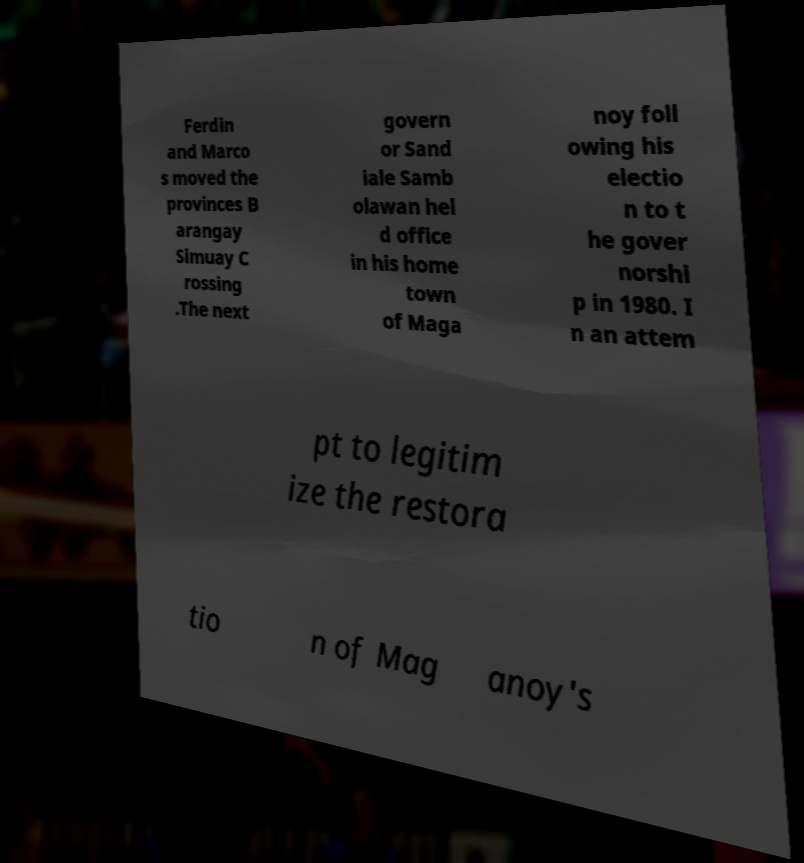There's text embedded in this image that I need extracted. Can you transcribe it verbatim? Ferdin and Marco s moved the provinces B arangay Simuay C rossing .The next govern or Sand iale Samb olawan hel d office in his home town of Maga noy foll owing his electio n to t he gover norshi p in 1980. I n an attem pt to legitim ize the restora tio n of Mag anoy's 